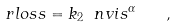<formula> <loc_0><loc_0><loc_500><loc_500>\ r l o s s = k _ { 2 } \ n v i s ^ { \alpha } \quad ,</formula> 